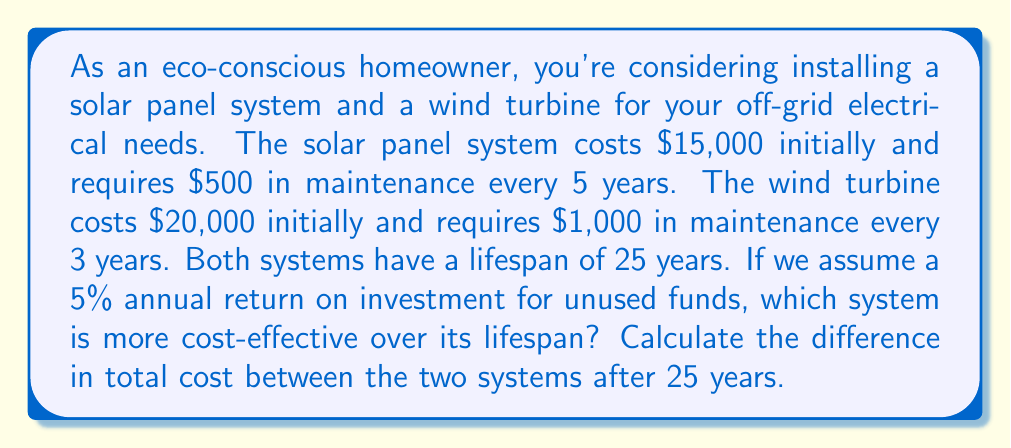Could you help me with this problem? To solve this problem, we need to calculate the present value of all costs for both systems over 25 years, considering the initial costs, periodic maintenance, and the time value of money.

1. Solar Panel System:
   Initial cost: $15,000
   Maintenance: $500 every 5 years

   Present value of maintenance costs:
   $$PV_{solar} = 500 \cdot \sum_{k=1}^5 \frac{1}{(1.05)^{5k}}$$
   $$PV_{solar} = 500 \cdot \frac{1-(1.05)^{-25}}{1-(1.05)^{-5}}$$
   $$PV_{solar} = 500 \cdot 3.3066 = 1,653.30$$

   Total cost for solar: $15,000 + $1,653.30 = $16,653.30

2. Wind Turbine System:
   Initial cost: $20,000
   Maintenance: $1,000 every 3 years

   Present value of maintenance costs:
   $$PV_{wind} = 1000 \cdot \sum_{k=1}^8 \frac{1}{(1.05)^{3k}}$$
   $$PV_{wind} = 1000 \cdot \frac{1-(1.05)^{-24}}{1-(1.05)^{-3}}$$
   $$PV_{wind} = 1000 \cdot 6.0673 = 6,067.30$$

   Total cost for wind: $20,000 + $6,067.30 = $26,067.30

3. Difference in total cost:
   $$\text{Difference} = \text{Wind Turbine Cost} - \text{Solar Panel Cost}$$
   $$\text{Difference} = 26,067.30 - 16,653.30 = 9,414.00$$
Answer: The solar panel system is more cost-effective. The difference in total cost over 25 years is $9,414.00, with the solar panel system being cheaper. 